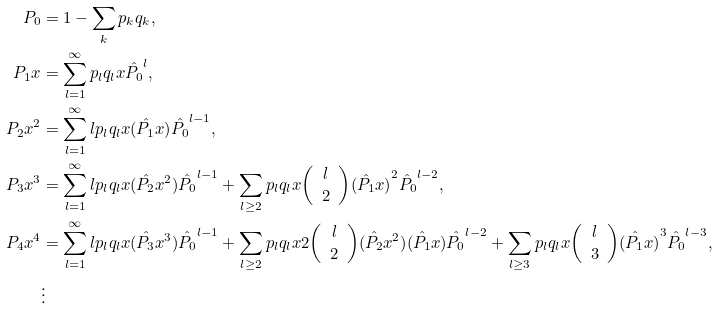<formula> <loc_0><loc_0><loc_500><loc_500>P _ { 0 } & = 1 - \sum _ { k } p _ { k } q _ { k } , \\ P _ { 1 } x & = \sum _ { l = 1 } ^ { \infty } { p _ { l } q _ { l } x \hat { P _ { 0 } } } ^ { l } , \\ P _ { 2 } { x } ^ { 2 } & = \sum _ { l = 1 } ^ { \infty } { l p _ { l } q _ { l } x ( \hat { P _ { 1 } } x ) } { \hat { P _ { 0 } } } ^ { l - 1 } , \\ P _ { 3 } { x } ^ { 3 } & = \sum _ { l = 1 } ^ { \infty } { l p _ { l } q _ { l } x ( \hat { P _ { 2 } } { x } ^ { 2 } ) \hat { P _ { 0 } } ^ { l - 1 } } + \sum _ { l \geq 2 } p _ { l } q _ { l } x { \left ( \begin{array} { c } l \\ 2 \end{array} \right ) } { ( \hat { P _ { 1 } } x ) } ^ { 2 } \hat { P _ { 0 } } ^ { l - 2 } , \\ P _ { 4 } { x } ^ { 4 } & = \sum _ { l = 1 } ^ { \infty } l p _ { l } q _ { l } x ( \hat { P _ { 3 } } { x } ^ { 3 } ) { \hat { P _ { 0 } } } ^ { l - 1 } + \sum _ { l \geq 2 } p _ { l } q _ { l } x 2 { \left ( \begin{array} { c } l \\ 2 \end{array} \right ) } { ( \hat { P _ { 2 } } x ^ { 2 } ) } ( \hat { P _ { 1 } } x ) { \hat { P _ { 0 } } } ^ { l - 2 } + \sum _ { l \geq 3 } p _ { l } q _ { l } x { \left ( \begin{array} { c } l \\ 3 \end{array} \right ) } { ( \hat { P _ { 1 } } x ) } ^ { 3 } { \hat { P _ { 0 } } } ^ { l - 3 } , \\ & \vdots</formula> 